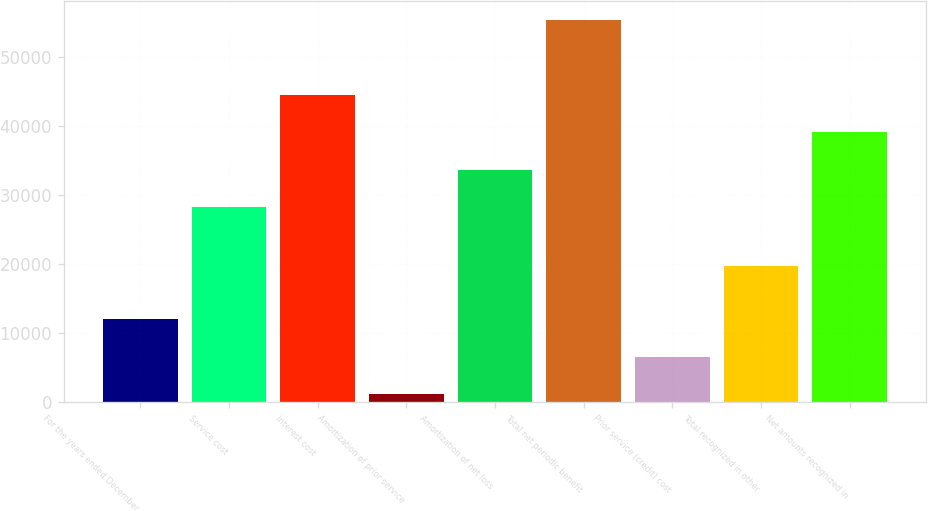<chart> <loc_0><loc_0><loc_500><loc_500><bar_chart><fcel>For the years ended December<fcel>Service cost<fcel>Interest cost<fcel>Amortization of prior service<fcel>Amortization of net loss<fcel>Total net periodic benefit<fcel>Prior service (credit) cost<fcel>Total recognized in other<fcel>Net amounts recognized in<nl><fcel>12014.4<fcel>28300<fcel>44554.6<fcel>1178<fcel>33718.2<fcel>55360<fcel>6596.2<fcel>19806<fcel>39136.4<nl></chart> 